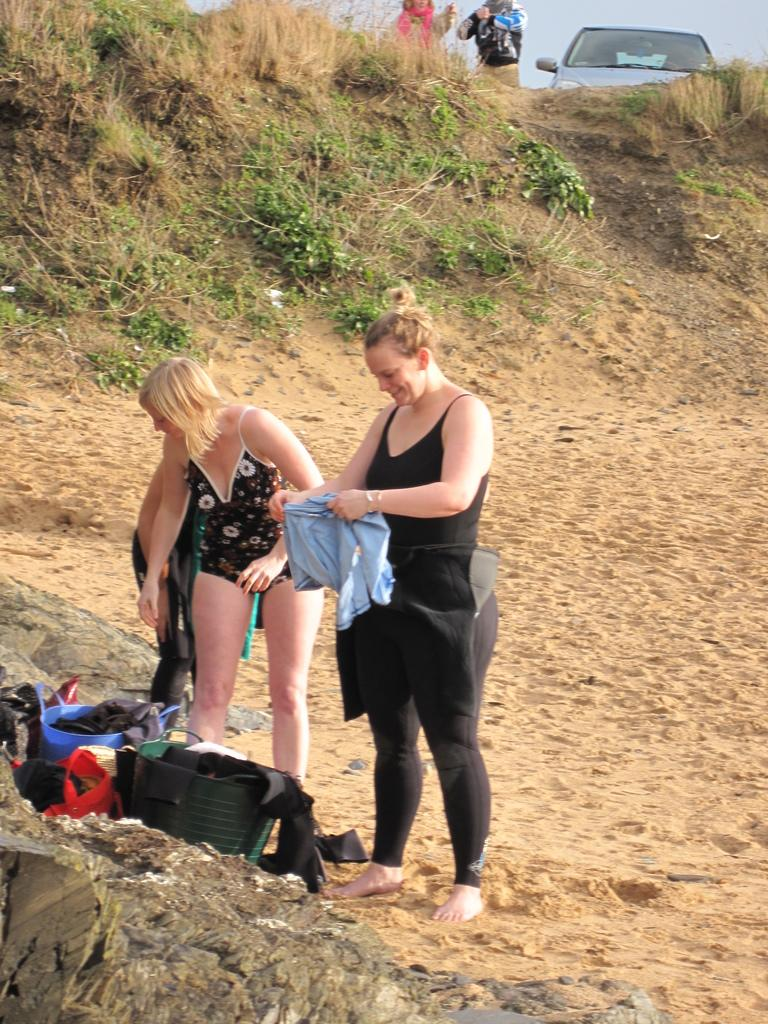How many people are present in the image? There are five persons standing in the image. What objects can be seen in the image besides the people? There are bags and a car visible in the image. What type of natural environment is visible in the image? There is grass visible in the image. What part of the natural environment is visible in the image? The sky is visible in the image. What type of shock can be seen affecting the persons in the image? There is no shock present in the image; the persons are standing calmly. What type of bucket is visible in the image? There is no bucket present in the image. 